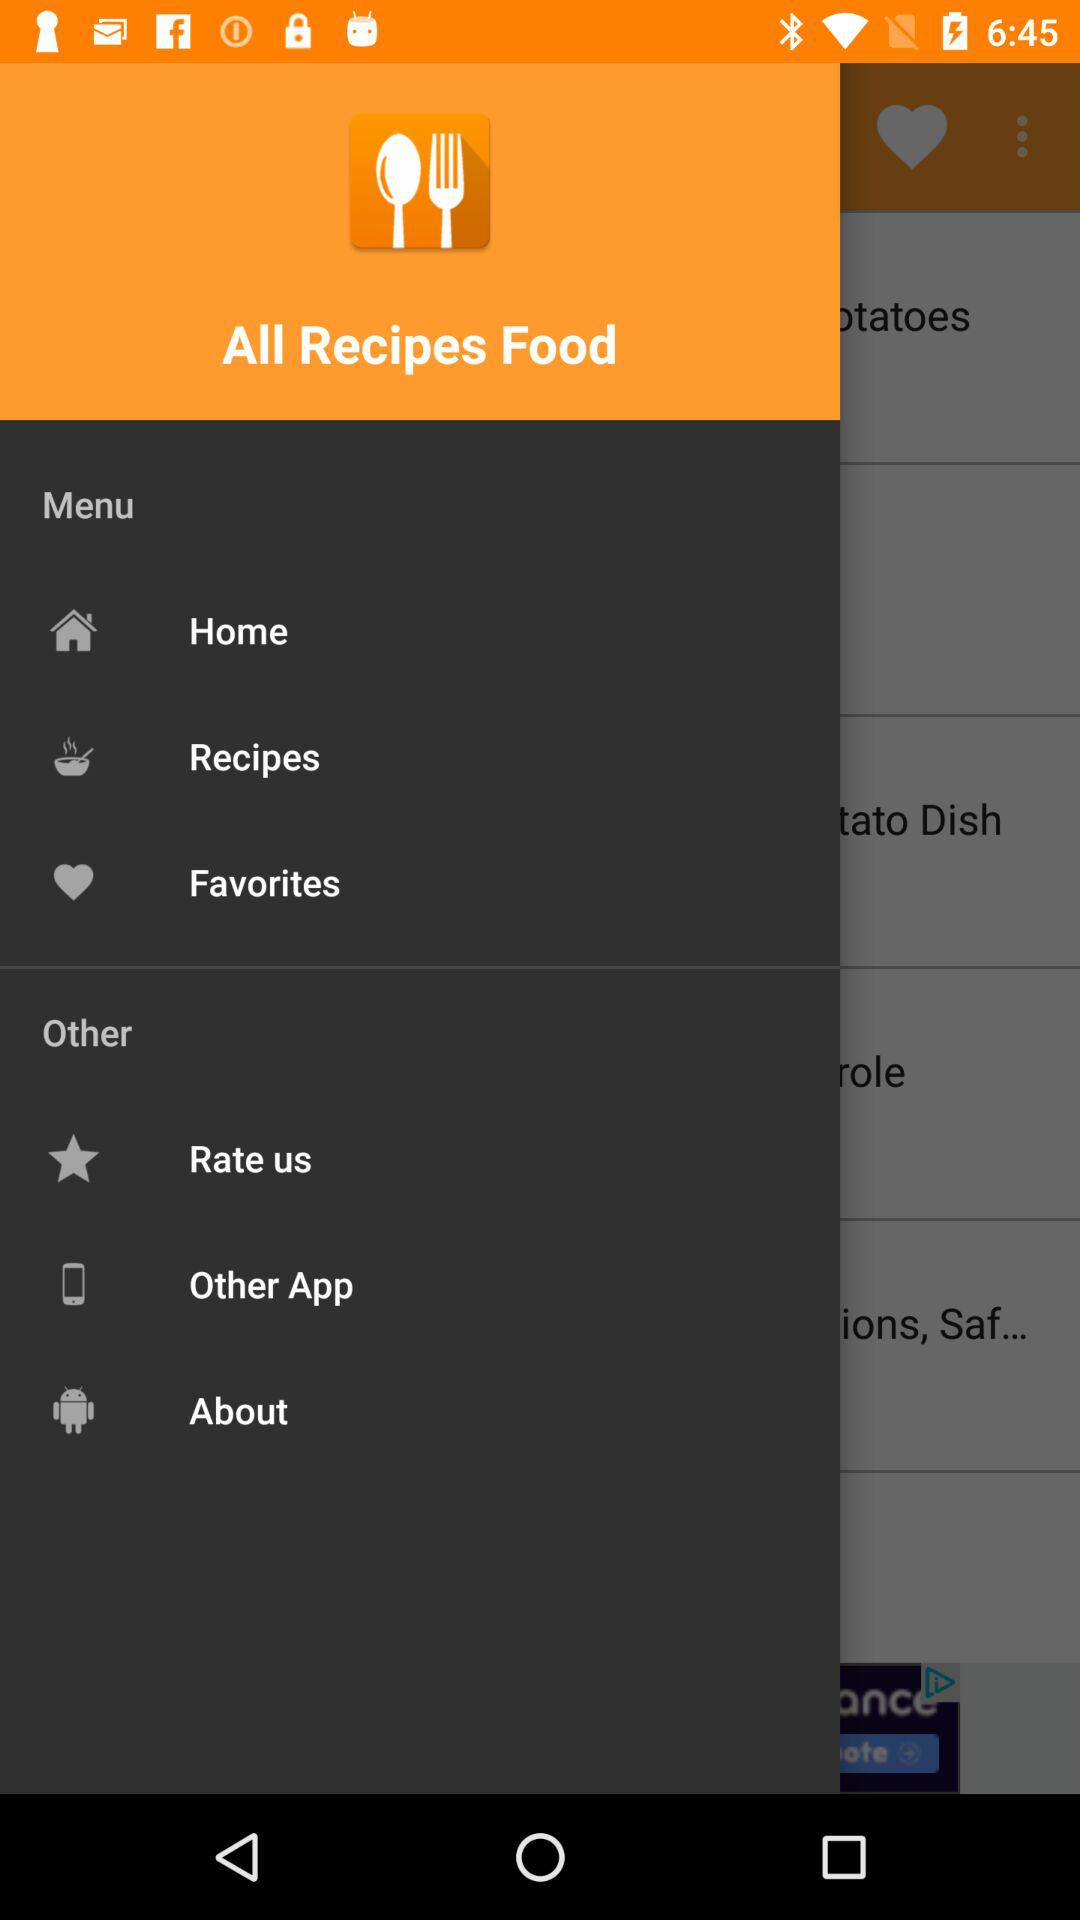What is the application name? The application name is "All Recipes Food". 